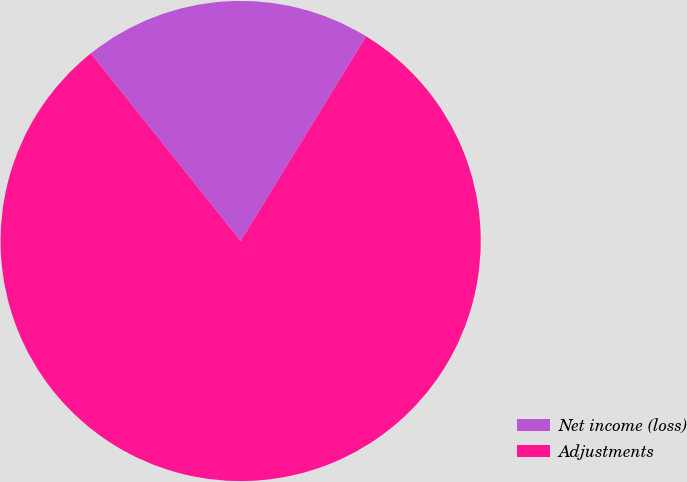<chart> <loc_0><loc_0><loc_500><loc_500><pie_chart><fcel>Net income (loss)<fcel>Adjustments<nl><fcel>19.48%<fcel>80.52%<nl></chart> 